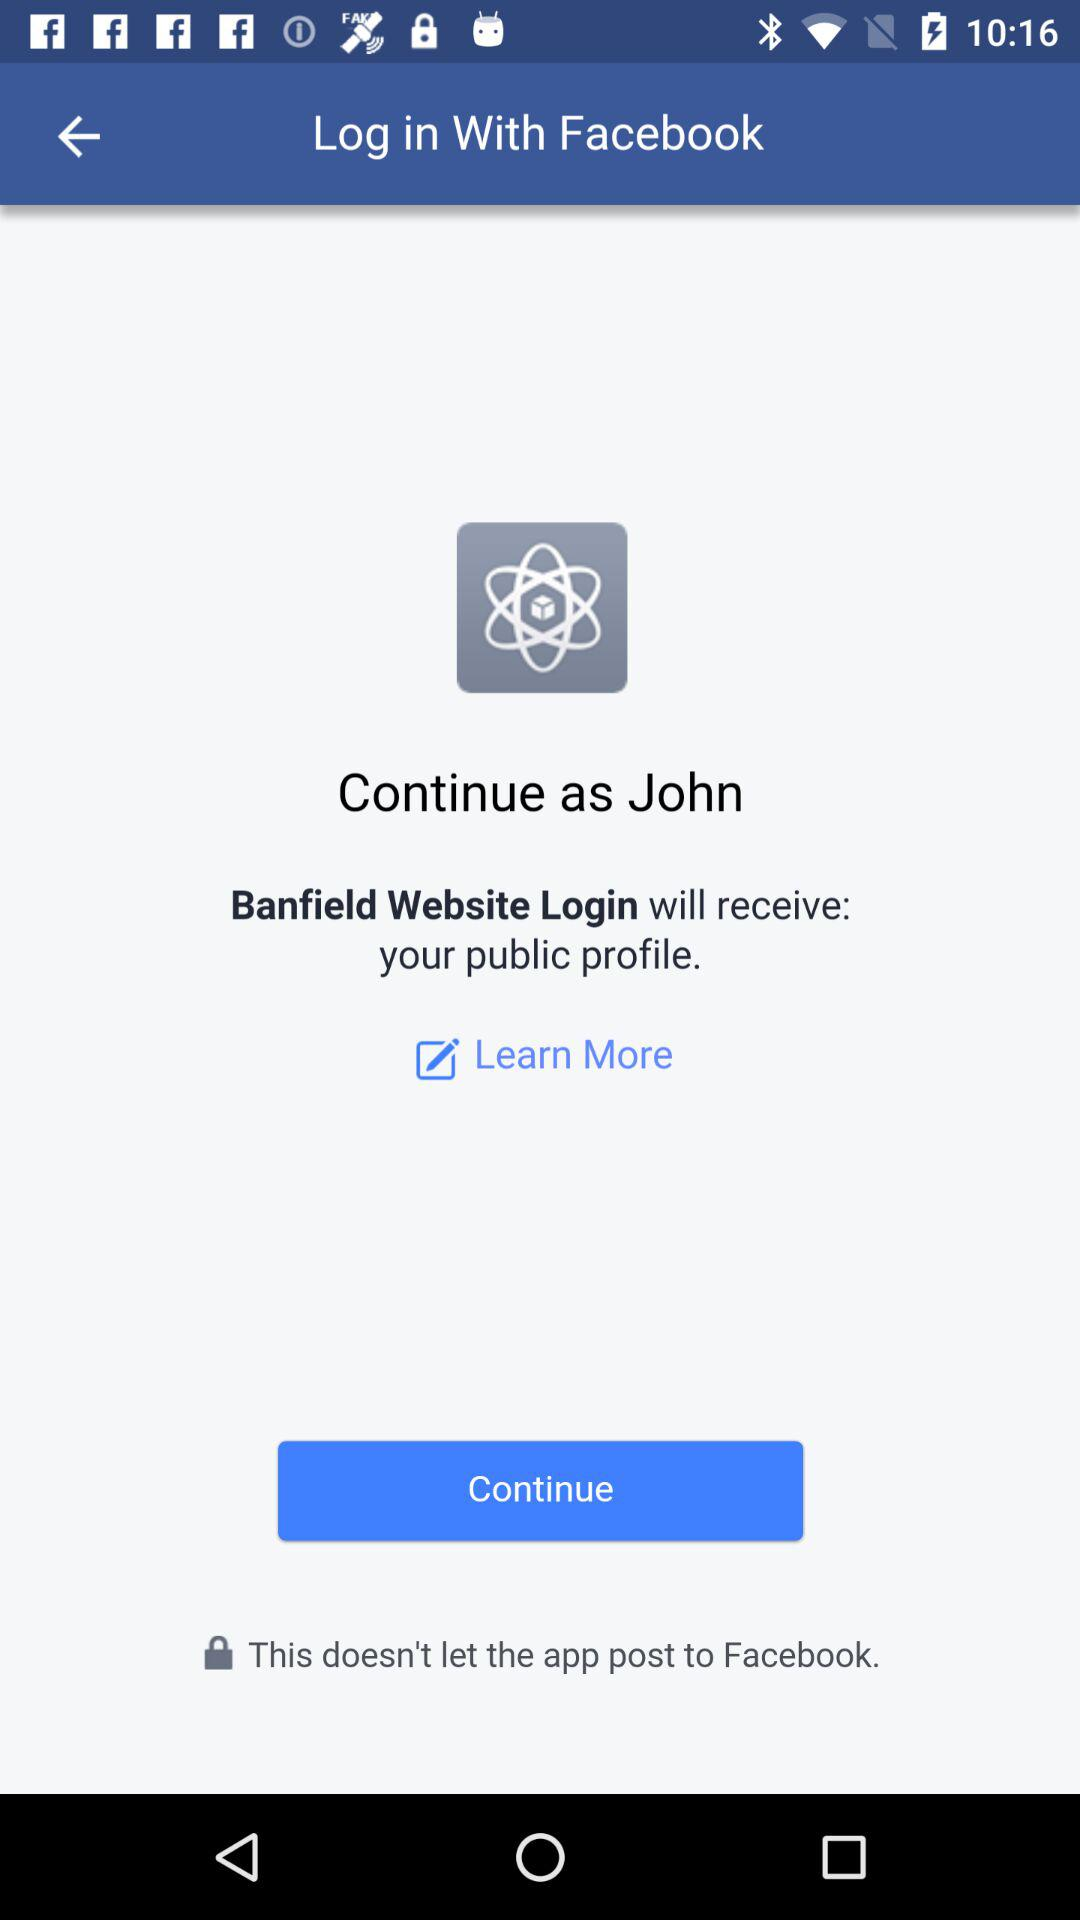Who will receive the public profile? The public profile will be received by "Banfield Website Login". 